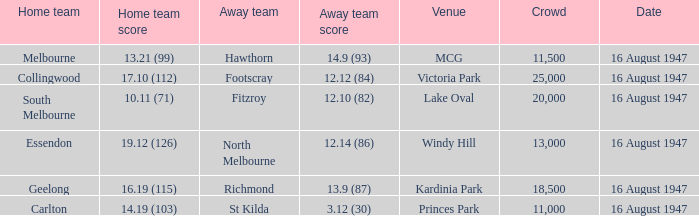How much did the away team score at victoria park? 12.12 (84). Parse the full table. {'header': ['Home team', 'Home team score', 'Away team', 'Away team score', 'Venue', 'Crowd', 'Date'], 'rows': [['Melbourne', '13.21 (99)', 'Hawthorn', '14.9 (93)', 'MCG', '11,500', '16 August 1947'], ['Collingwood', '17.10 (112)', 'Footscray', '12.12 (84)', 'Victoria Park', '25,000', '16 August 1947'], ['South Melbourne', '10.11 (71)', 'Fitzroy', '12.10 (82)', 'Lake Oval', '20,000', '16 August 1947'], ['Essendon', '19.12 (126)', 'North Melbourne', '12.14 (86)', 'Windy Hill', '13,000', '16 August 1947'], ['Geelong', '16.19 (115)', 'Richmond', '13.9 (87)', 'Kardinia Park', '18,500', '16 August 1947'], ['Carlton', '14.19 (103)', 'St Kilda', '3.12 (30)', 'Princes Park', '11,000', '16 August 1947']]} 